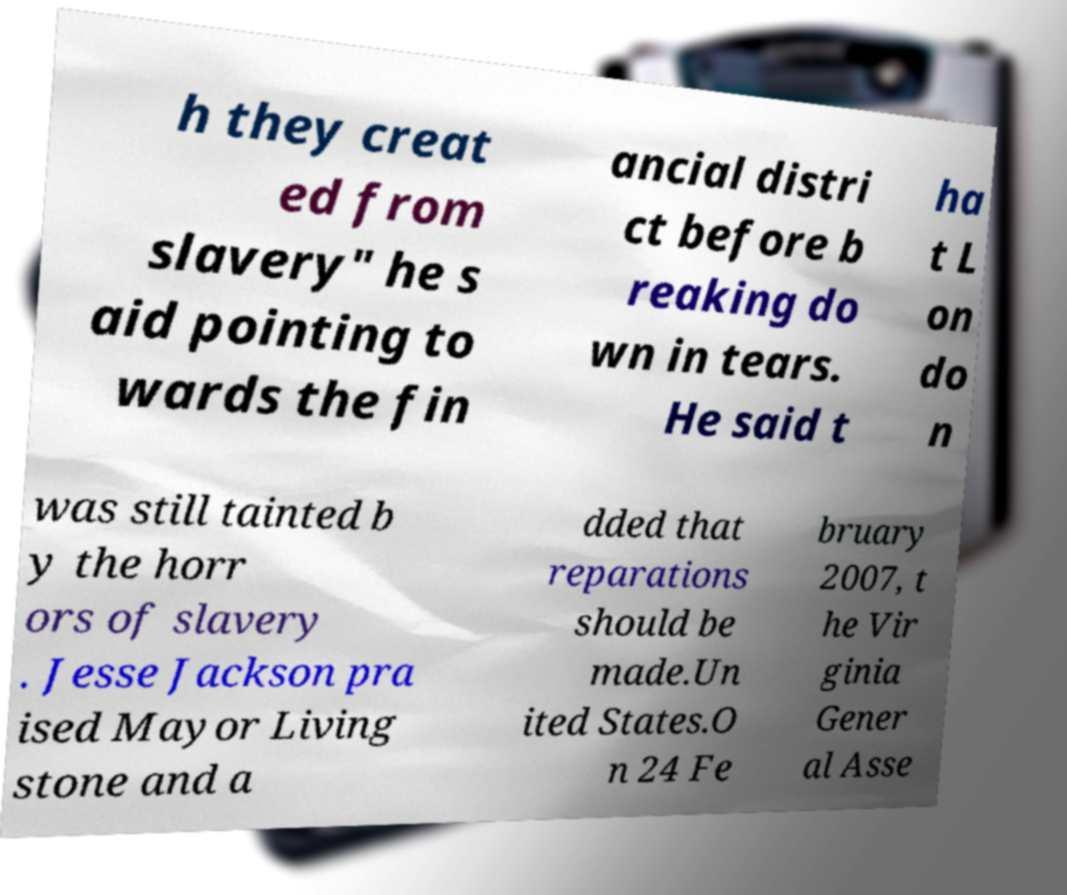Please read and relay the text visible in this image. What does it say? h they creat ed from slavery" he s aid pointing to wards the fin ancial distri ct before b reaking do wn in tears. He said t ha t L on do n was still tainted b y the horr ors of slavery . Jesse Jackson pra ised Mayor Living stone and a dded that reparations should be made.Un ited States.O n 24 Fe bruary 2007, t he Vir ginia Gener al Asse 